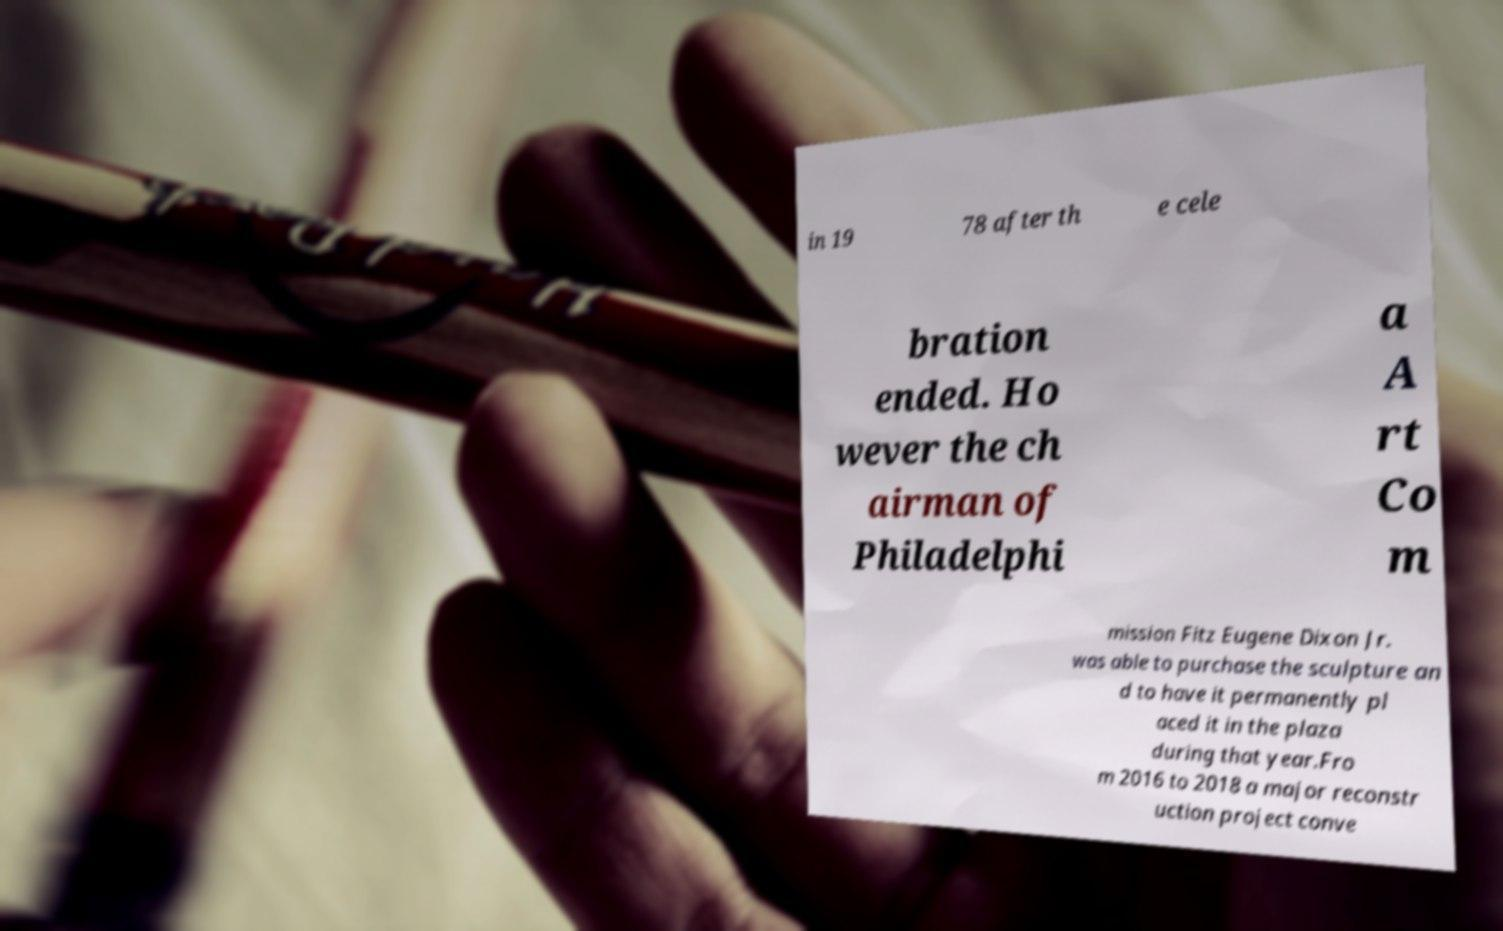Can you accurately transcribe the text from the provided image for me? in 19 78 after th e cele bration ended. Ho wever the ch airman of Philadelphi a A rt Co m mission Fitz Eugene Dixon Jr. was able to purchase the sculpture an d to have it permanently pl aced it in the plaza during that year.Fro m 2016 to 2018 a major reconstr uction project conve 